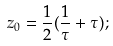<formula> <loc_0><loc_0><loc_500><loc_500>z _ { 0 } = \frac { 1 } { 2 } ( \frac { 1 } { \tau } + \tau ) ;</formula> 